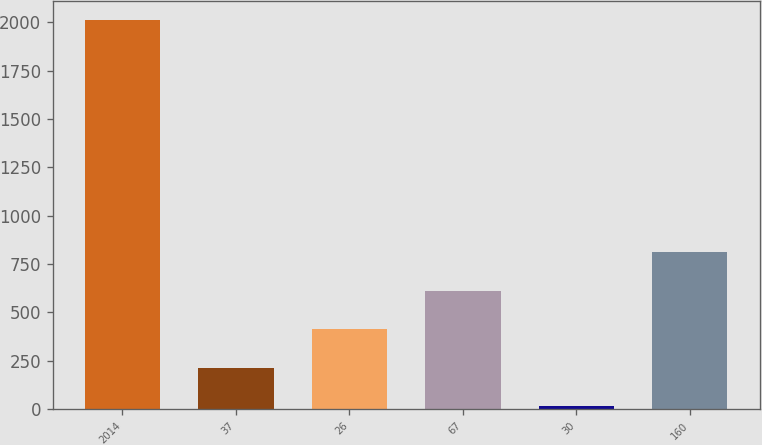Convert chart. <chart><loc_0><loc_0><loc_500><loc_500><bar_chart><fcel>2014<fcel>37<fcel>26<fcel>67<fcel>30<fcel>160<nl><fcel>2012<fcel>213.8<fcel>413.6<fcel>613.4<fcel>14<fcel>813.2<nl></chart> 